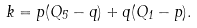<formula> <loc_0><loc_0><loc_500><loc_500>k = p ( Q _ { 5 } - q ) + q ( Q _ { 1 } - p ) .</formula> 